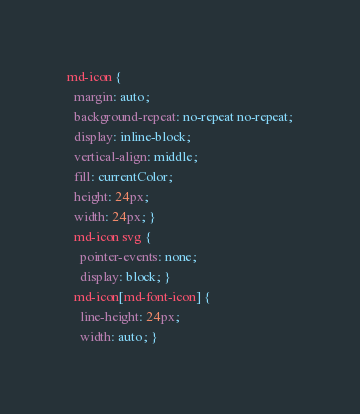<code> <loc_0><loc_0><loc_500><loc_500><_CSS_>
md-icon {
  margin: auto;
  background-repeat: no-repeat no-repeat;
  display: inline-block;
  vertical-align: middle;
  fill: currentColor;
  height: 24px;
  width: 24px; }
  md-icon svg {
    pointer-events: none;
    display: block; }
  md-icon[md-font-icon] {
    line-height: 24px;
    width: auto; }
</code> 